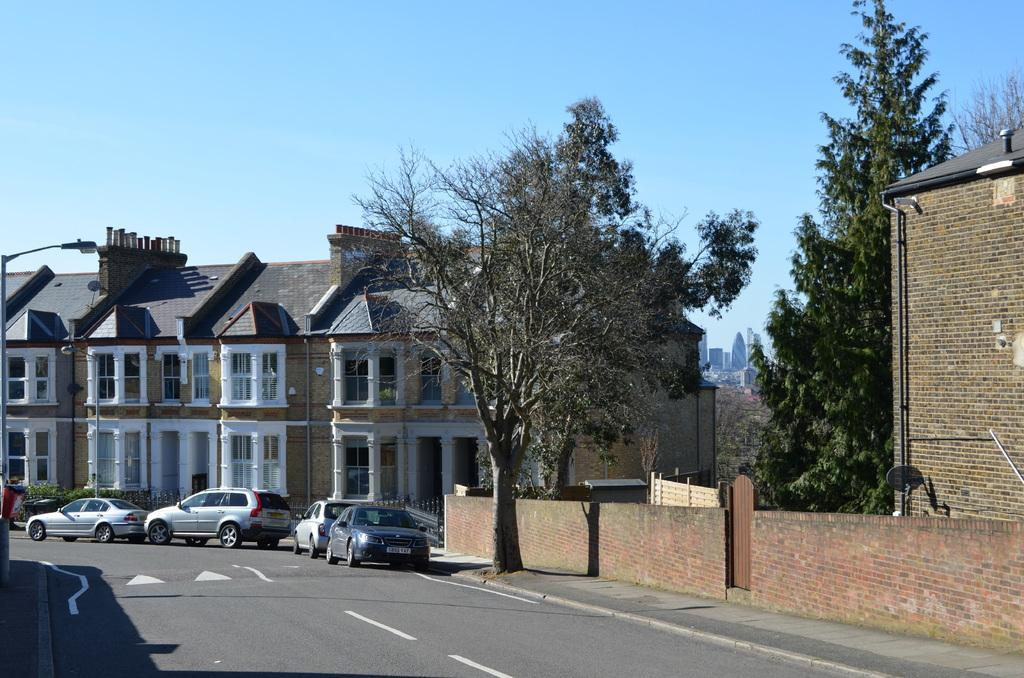What type of structures can be seen in the image? There are buildings in the image. What other natural elements are present in the image? There are trees in the image. What mode of transportation can be seen on the road at the bottom of the image? Cars are visible on the road at the bottom of the image. What is visible in the background of the image? There is sky visible in the background of the image. What object is located on the left side of the image? There is a pole on the left side of the image. What type of underwear is hanging on the pole in the image? There is no underwear present in the image; only a pole can be seen on the left side of the image. What type of polish is being applied to the buildings in the image? There is no polish being applied to the buildings in the image; the image simply shows the buildings as they are. 